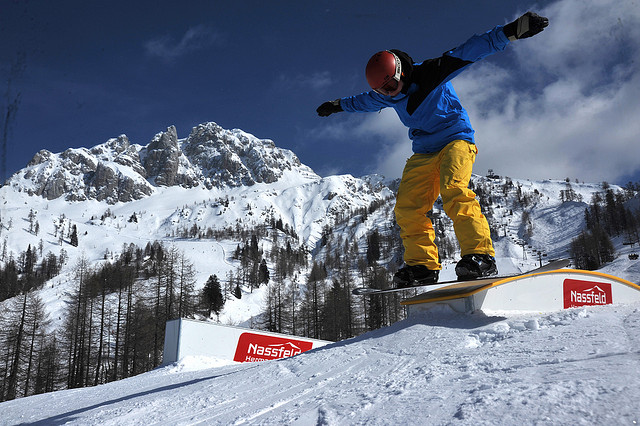What's the weather like in the photo? The weather in the photo appears to be clear and sunny, with a bright blue sky overhead. The abundance of snow on the ground and the mountains suggests cold, wintry conditions typical of a high-altitude environment. 